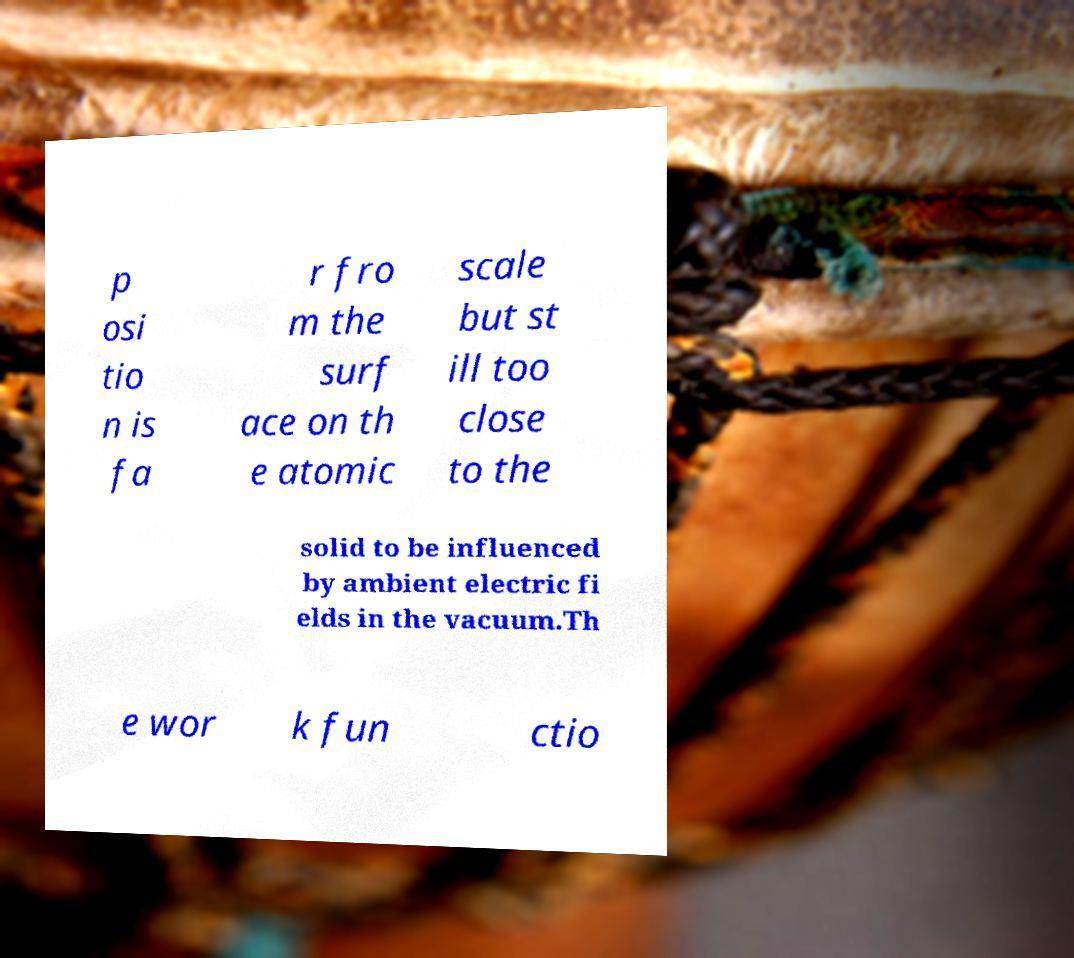For documentation purposes, I need the text within this image transcribed. Could you provide that? p osi tio n is fa r fro m the surf ace on th e atomic scale but st ill too close to the solid to be influenced by ambient electric fi elds in the vacuum.Th e wor k fun ctio 